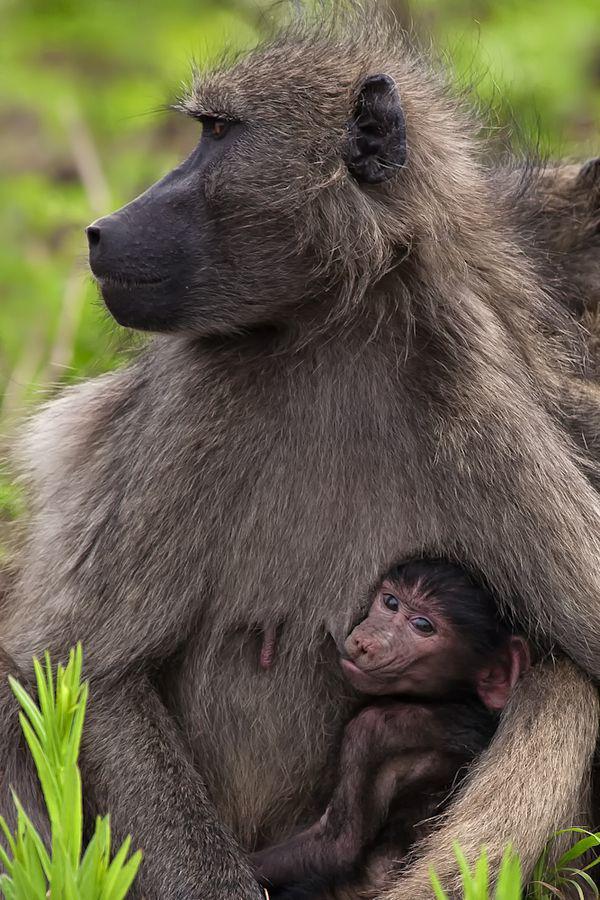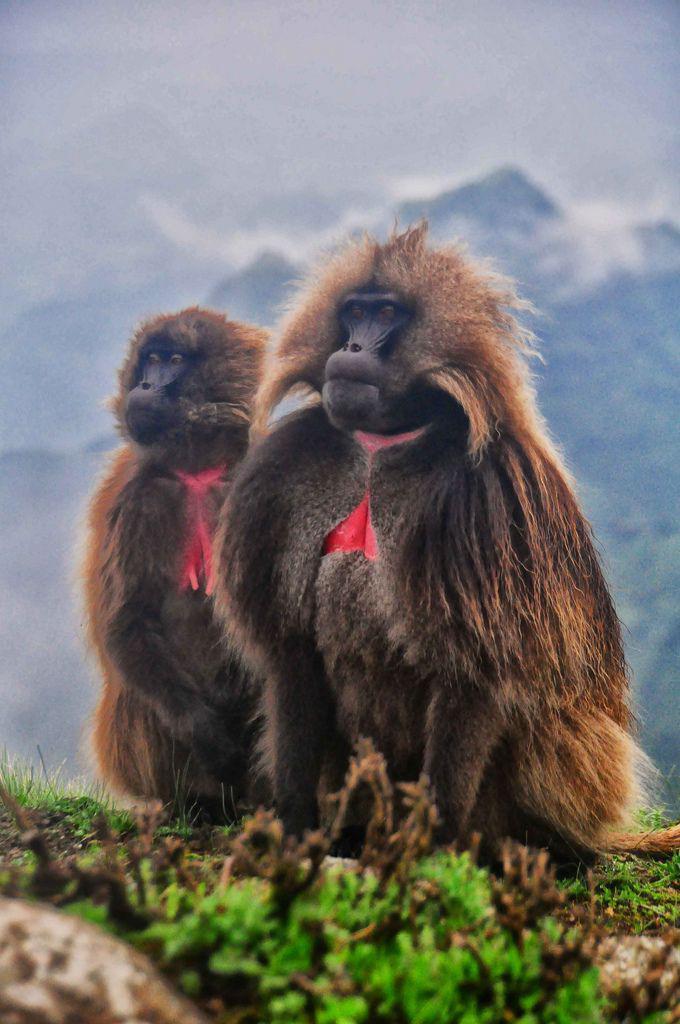The first image is the image on the left, the second image is the image on the right. For the images displayed, is the sentence "there are three monkeys in the image to the right." factually correct? Answer yes or no. No. The first image is the image on the left, the second image is the image on the right. Evaluate the accuracy of this statement regarding the images: "The left image contains exactly one primate.". Is it true? Answer yes or no. No. 